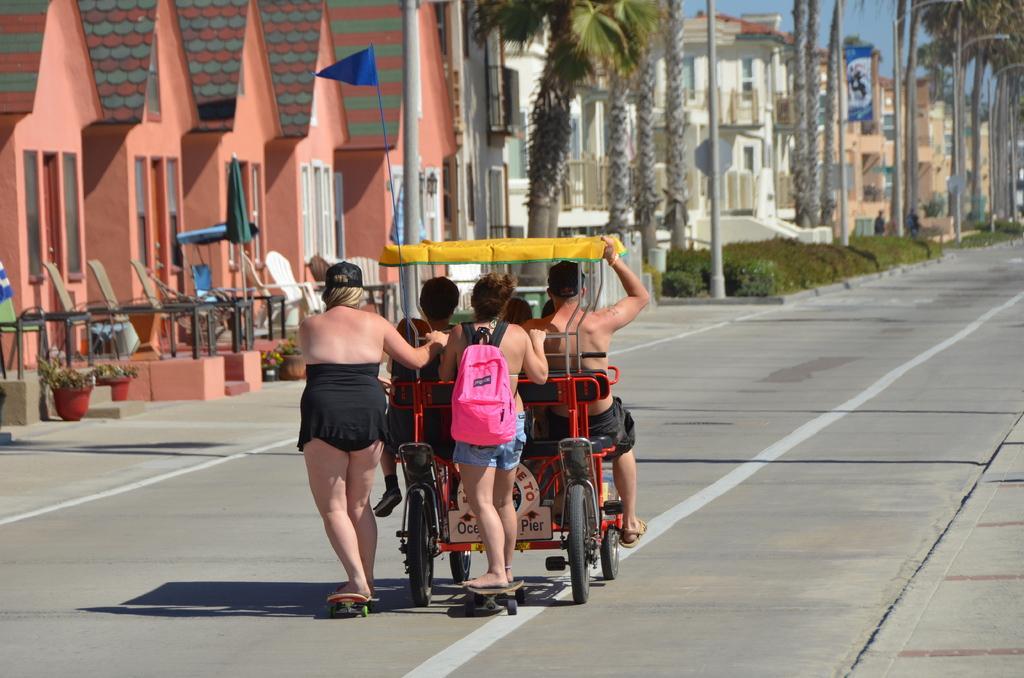Please provide a concise description of this image. In the middle of the picture we can see people skating and a vehicle moving on the road. In the background there are houses, chairs, poles, flag, trees and board. At the top there is sky. 